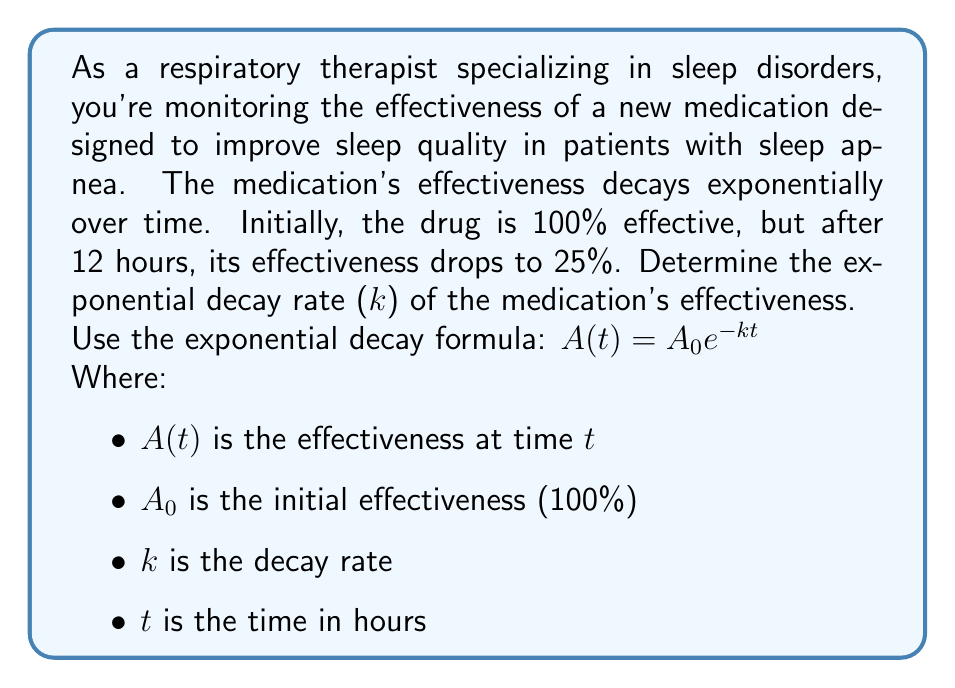Solve this math problem. To solve this problem, we'll use the exponential decay formula and the given information:

1. Initial effectiveness $A_0 = 100\%$
2. After 12 hours $(t = 12)$, effectiveness $A(12) = 25\%$

Let's plug these values into the formula:

$$25 = 100 e^{-k(12)}$$

Now, let's solve for $k$:

1. Divide both sides by 100:
   $$0.25 = e^{-12k}$$

2. Take the natural logarithm of both sides:
   $$\ln(0.25) = \ln(e^{-12k})$$

3. Simplify the right side using the properties of logarithms:
   $$\ln(0.25) = -12k$$

4. Solve for $k$:
   $$k = -\frac{\ln(0.25)}{12}$$

5. Calculate the value:
   $$k = -\frac{\ln(0.25)}{12} \approx 0.1155$$

The decay rate $k$ is approximately 0.1155 per hour.
Answer: The exponential decay rate (k) of the medication's effectiveness is approximately 0.1155 per hour. 